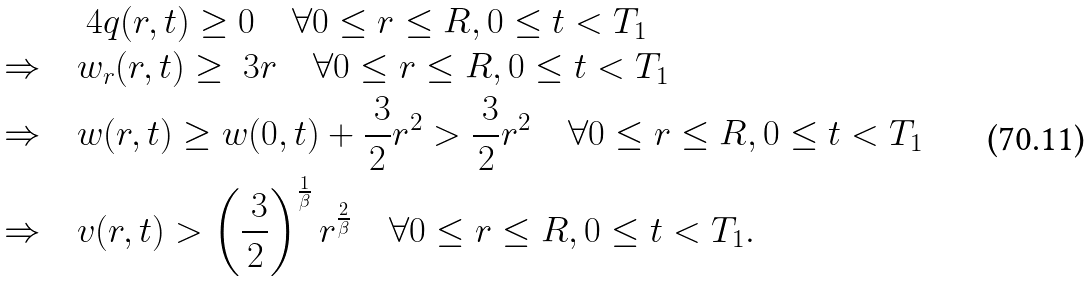Convert formula to latex. <formula><loc_0><loc_0><loc_500><loc_500>& \ 4 { q } ( r , t ) \geq 0 \quad \forall 0 \leq r \leq R , 0 \leq t < T _ { 1 } \\ \Rightarrow \quad & w _ { r } ( r , t ) \geq \ 3 r \quad \forall 0 \leq r \leq R , 0 \leq t < T _ { 1 } \\ \Rightarrow \quad & w ( r , t ) \geq w ( 0 , t ) + \frac { \ 3 } { 2 } r ^ { 2 } > \frac { \ 3 } { 2 } r ^ { 2 } \quad \forall 0 \leq r \leq R , 0 \leq t < T _ { 1 } \\ \Rightarrow \quad & v ( r , t ) > \left ( \frac { \ 3 } { 2 } \right ) ^ { \frac { 1 } { \beta } } r ^ { \frac { 2 } { \beta } } \quad \forall 0 \leq r \leq R , 0 \leq t < T _ { 1 } .</formula> 